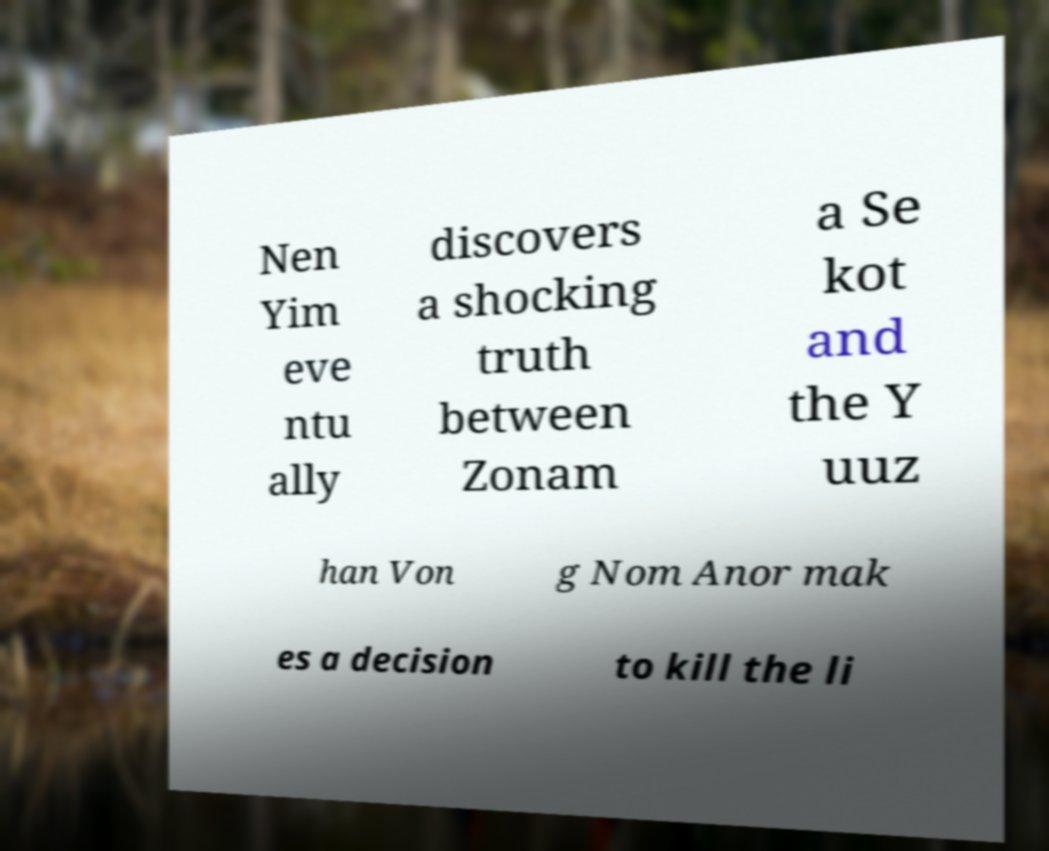Could you assist in decoding the text presented in this image and type it out clearly? Nen Yim eve ntu ally discovers a shocking truth between Zonam a Se kot and the Y uuz han Von g Nom Anor mak es a decision to kill the li 